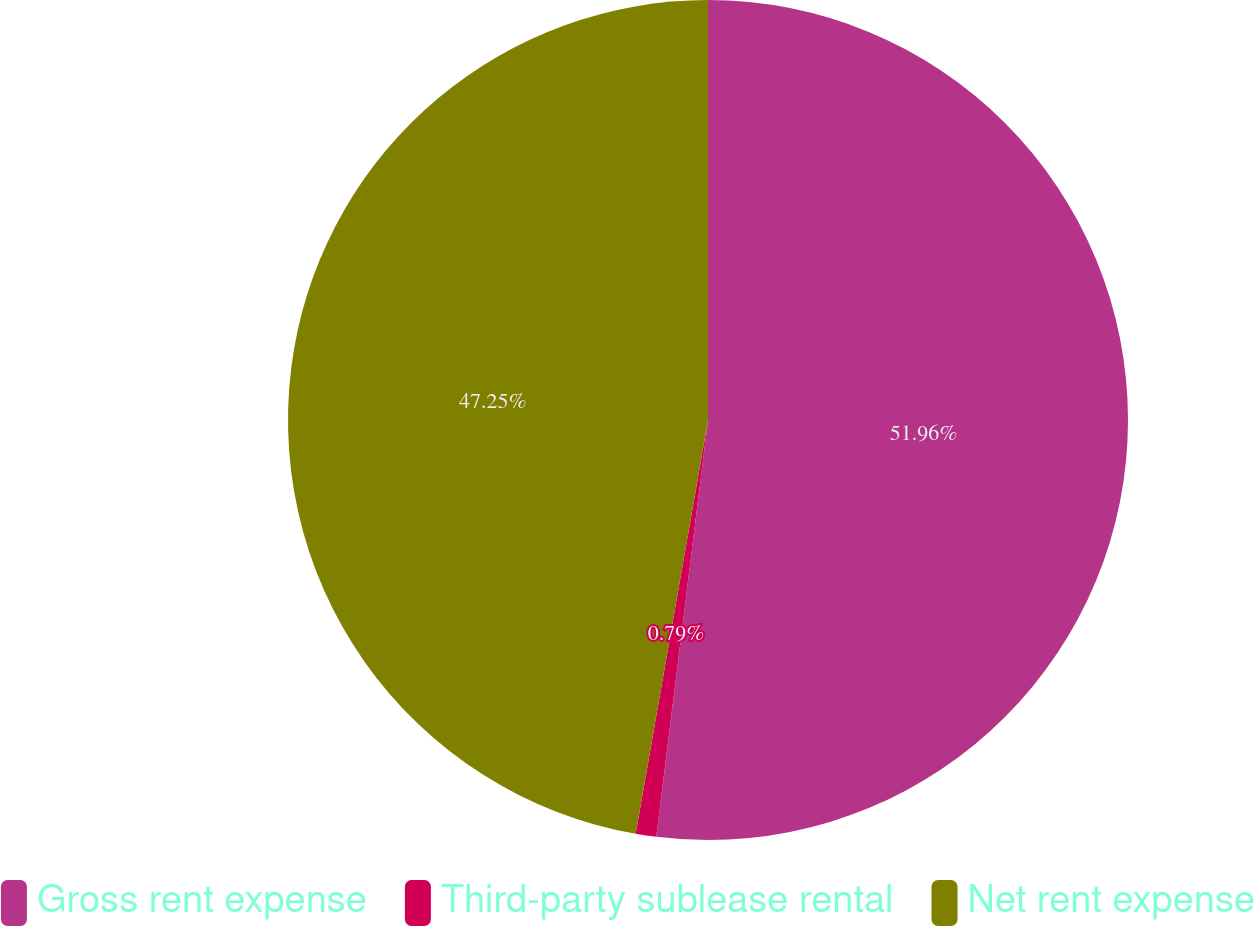Convert chart to OTSL. <chart><loc_0><loc_0><loc_500><loc_500><pie_chart><fcel>Gross rent expense<fcel>Third-party sublease rental<fcel>Net rent expense<nl><fcel>51.97%<fcel>0.79%<fcel>47.25%<nl></chart> 